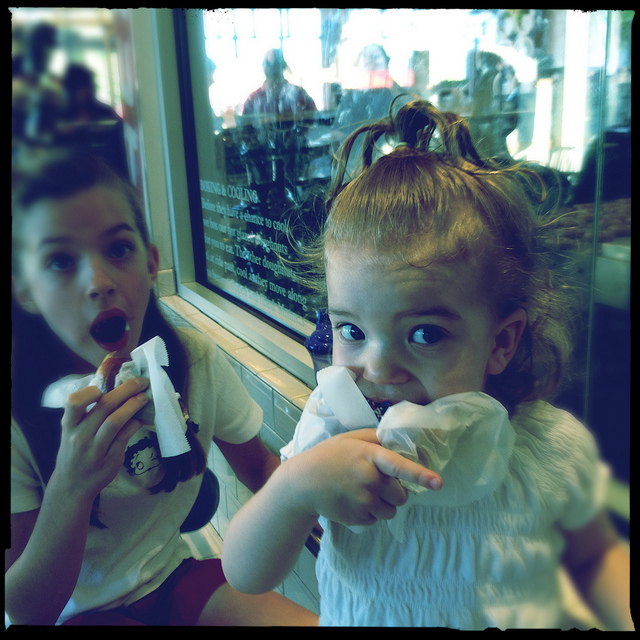Please identify all text content in this image. COOLING 